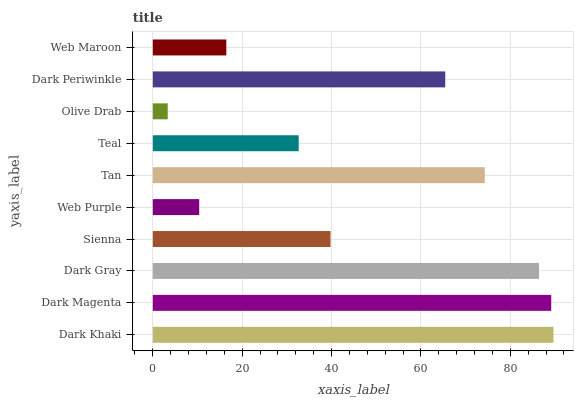Is Olive Drab the minimum?
Answer yes or no. Yes. Is Dark Khaki the maximum?
Answer yes or no. Yes. Is Dark Magenta the minimum?
Answer yes or no. No. Is Dark Magenta the maximum?
Answer yes or no. No. Is Dark Khaki greater than Dark Magenta?
Answer yes or no. Yes. Is Dark Magenta less than Dark Khaki?
Answer yes or no. Yes. Is Dark Magenta greater than Dark Khaki?
Answer yes or no. No. Is Dark Khaki less than Dark Magenta?
Answer yes or no. No. Is Dark Periwinkle the high median?
Answer yes or no. Yes. Is Sienna the low median?
Answer yes or no. Yes. Is Web Purple the high median?
Answer yes or no. No. Is Teal the low median?
Answer yes or no. No. 